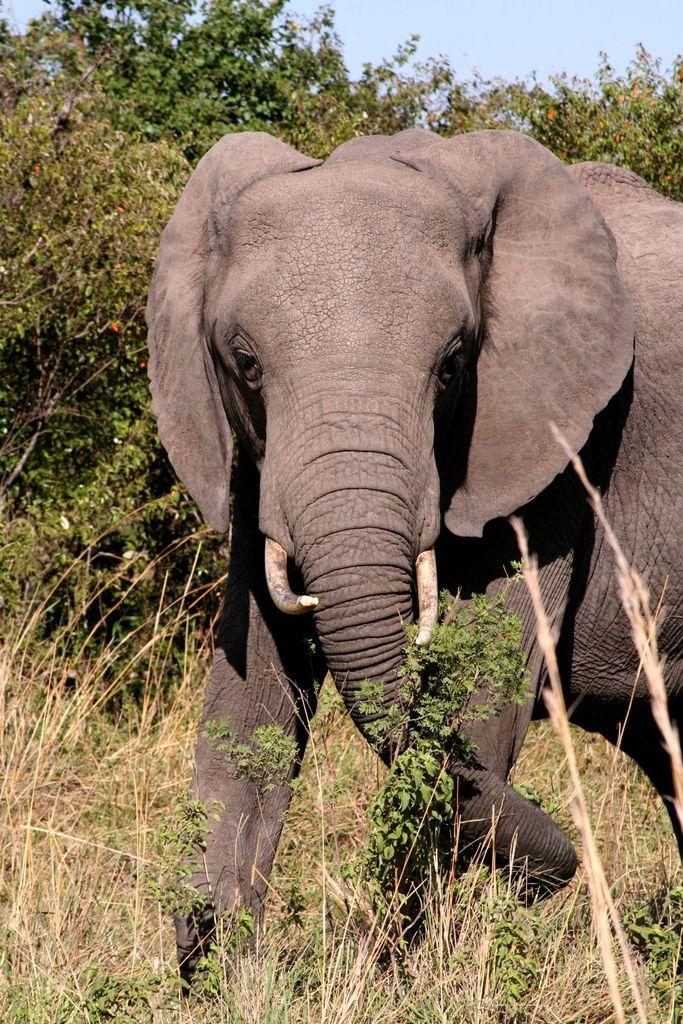What animal is present in the image? There is an elephant in the image. What type of vegetation can be seen in the image? There are trees in the image. What part of the natural environment is visible in the image? The sky is visible in the image. What type of pickle is being used as a decoration on the elephant's back in the image? There is no pickle present in the image, nor is there any decoration on the elephant's back. 